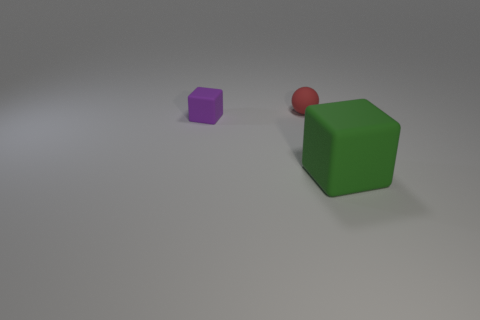Add 2 blocks. How many objects exist? 5 Subtract all purple cubes. How many cubes are left? 1 Subtract all spheres. How many objects are left? 2 Subtract 1 balls. How many balls are left? 0 Subtract all purple cylinders. How many green cubes are left? 1 Add 2 tiny things. How many tiny things are left? 4 Add 3 purple things. How many purple things exist? 4 Subtract 0 yellow blocks. How many objects are left? 3 Subtract all blue cubes. Subtract all red cylinders. How many cubes are left? 2 Subtract all matte things. Subtract all big gray metallic things. How many objects are left? 0 